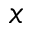<formula> <loc_0><loc_0><loc_500><loc_500>x</formula> 